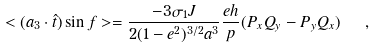Convert formula to latex. <formula><loc_0><loc_0><loc_500><loc_500>< ( { a } _ { 3 } \cdot \hat { t } ) \sin f > = \frac { - 3 \sigma _ { 1 } J } { 2 ( 1 - e ^ { 2 } ) ^ { 3 / 2 } a ^ { 3 } } \frac { e h } { p } ( P _ { x } Q _ { y } - P _ { y } Q _ { x } ) \ \ ,</formula> 